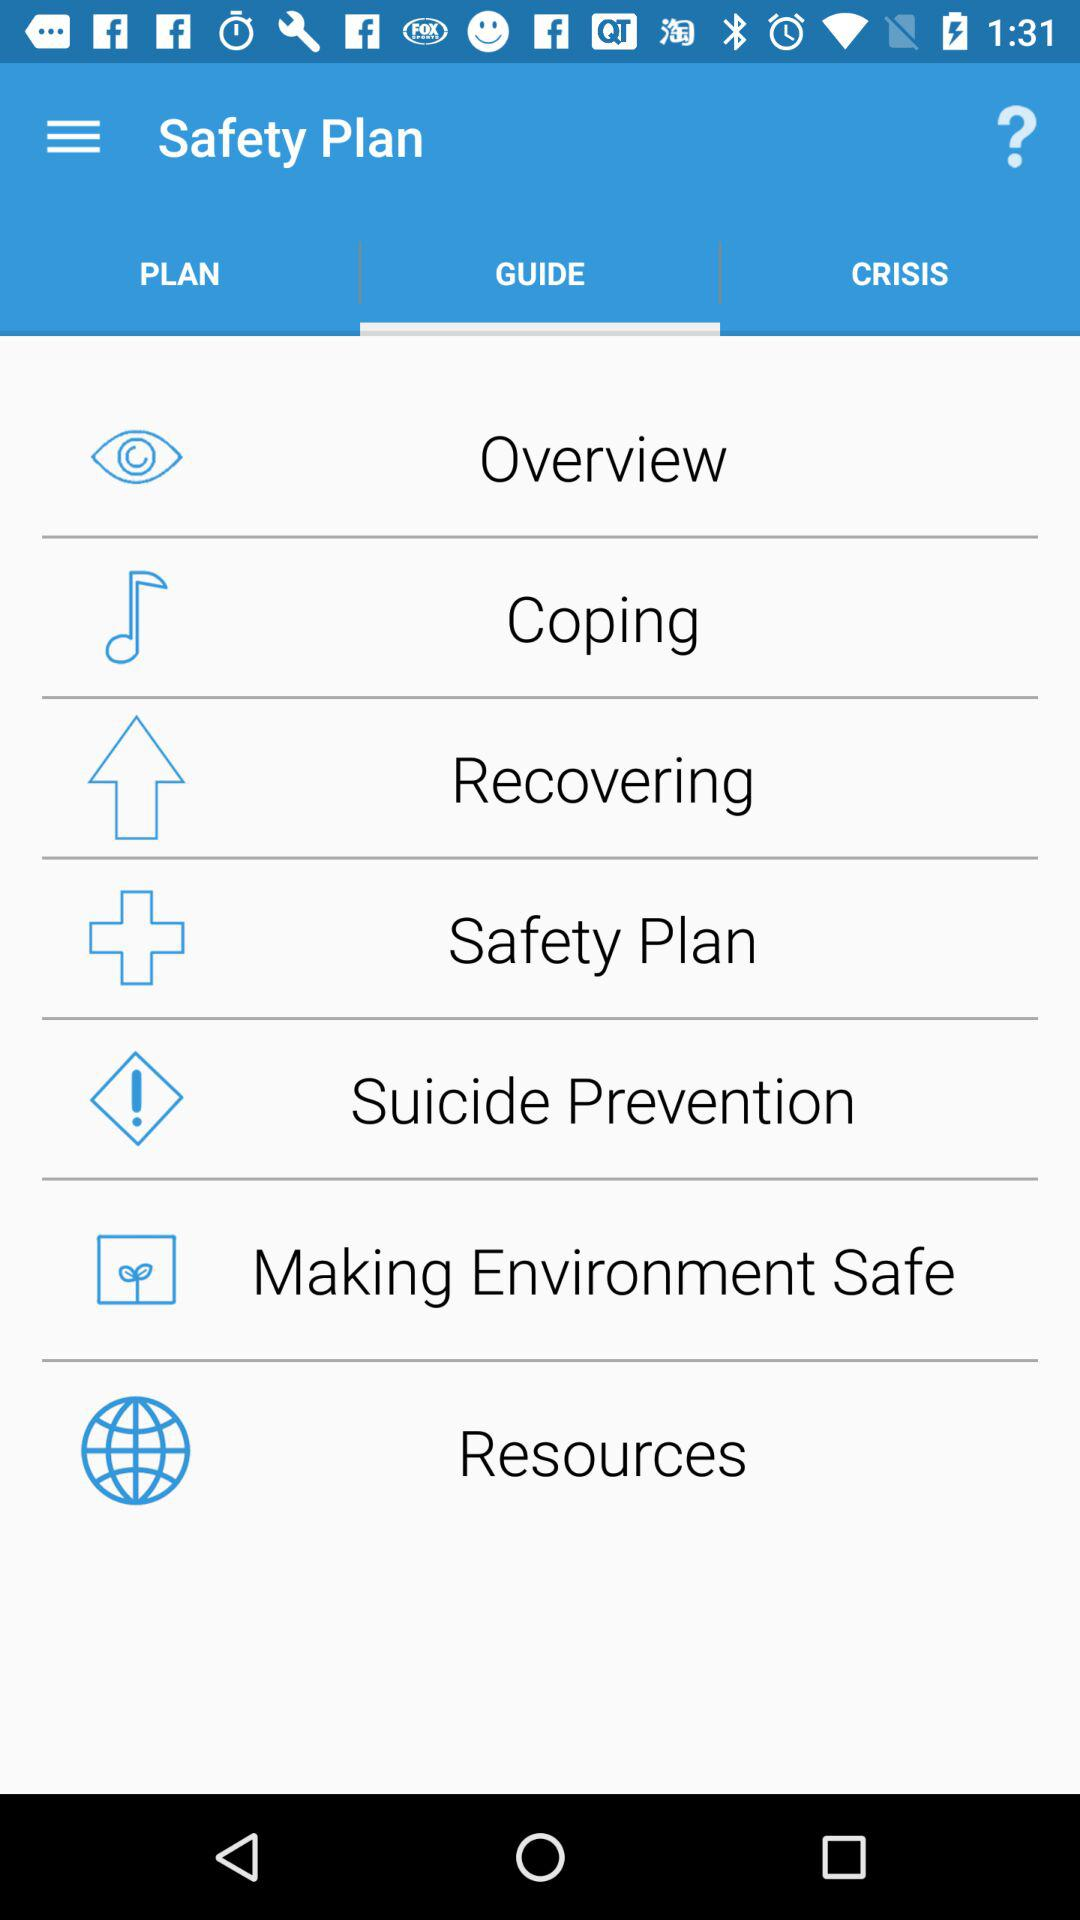Which tab is currently selected? The currently selected tab is "GUIDE". 